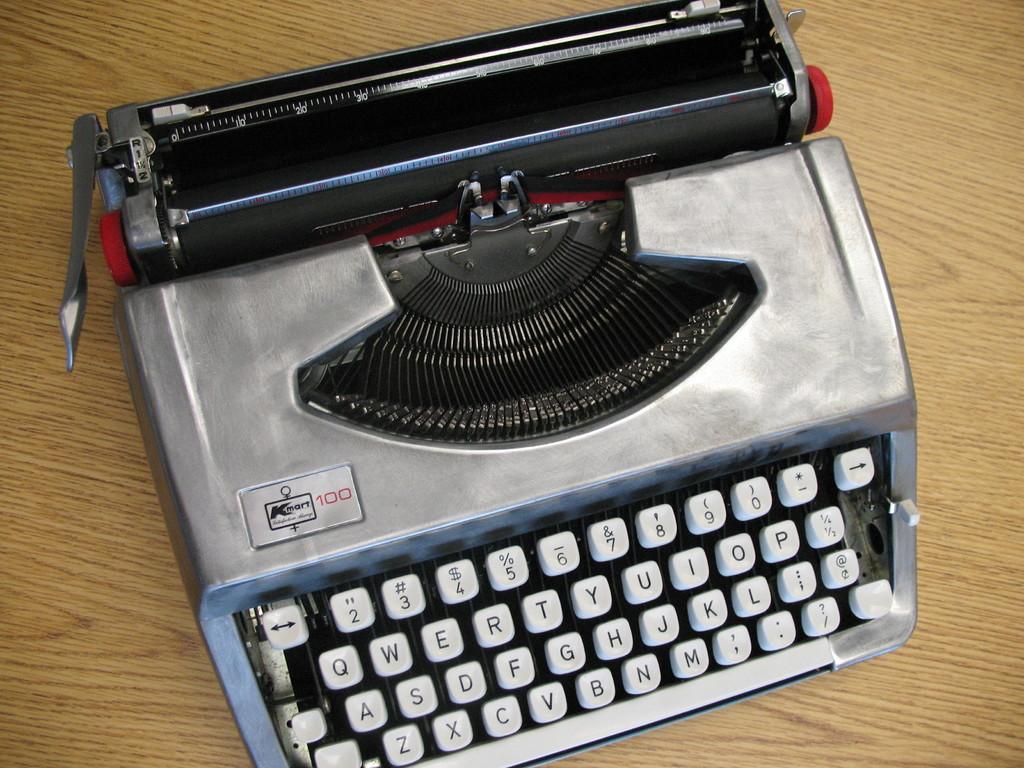What is the maker of the typewriter?
Make the answer very short. Kmart. What is the brand of that type writer?
Provide a short and direct response. Kmart. 